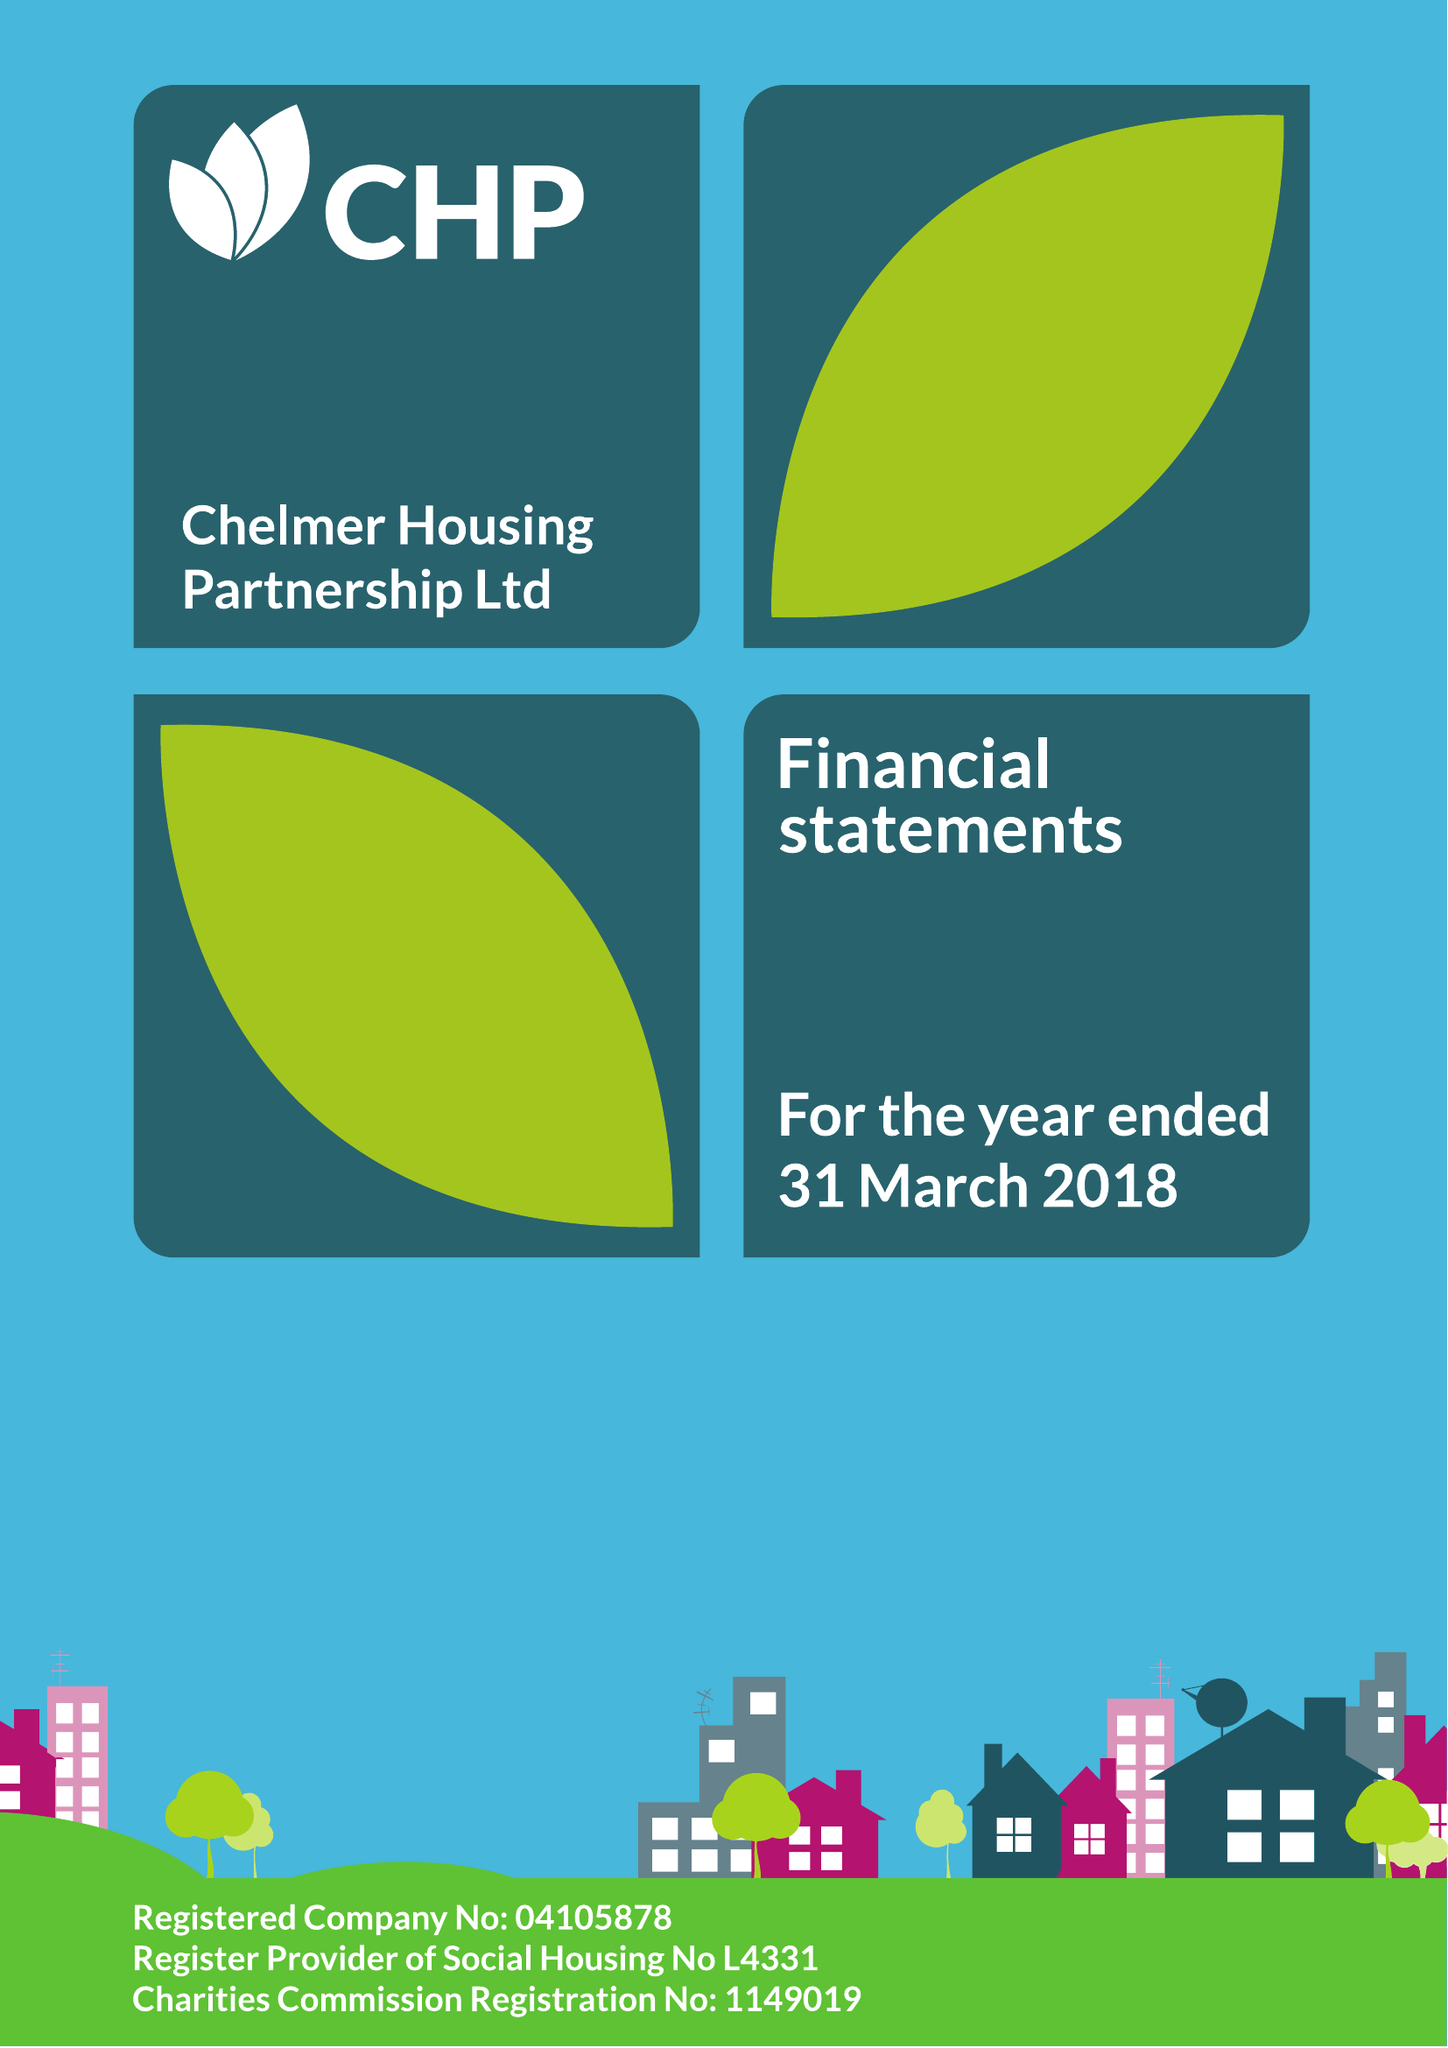What is the value for the address__post_town?
Answer the question using a single word or phrase. CHELMSFORD 